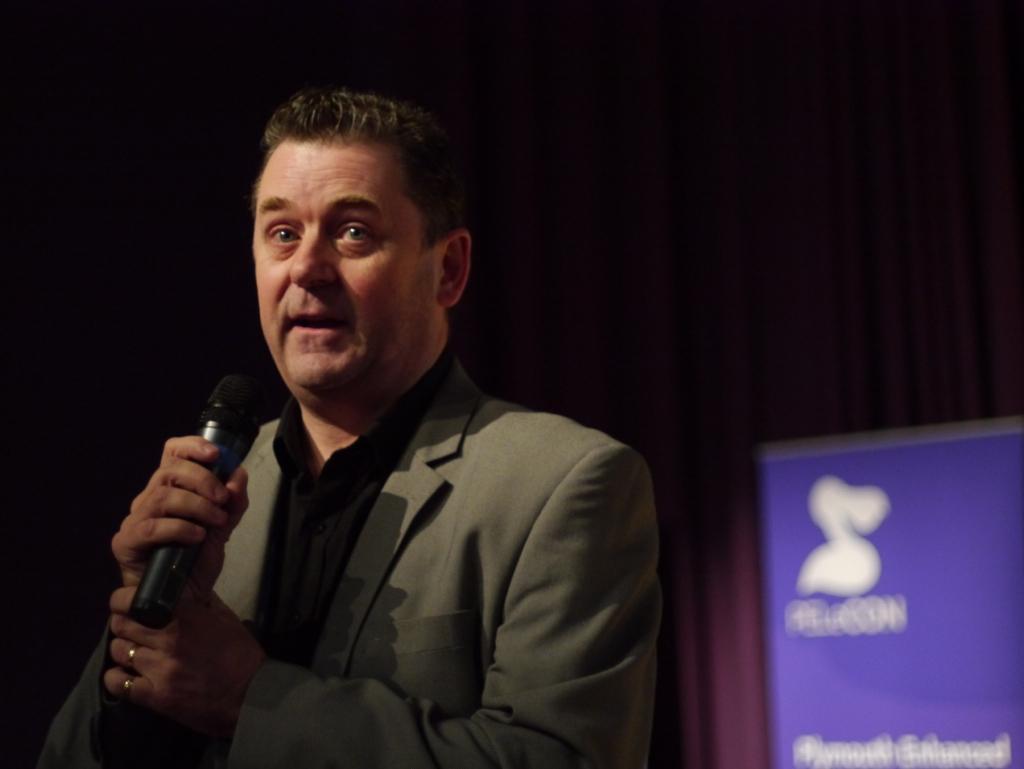Describe this image in one or two sentences. In this picture a man is standing and he is talking with the help of microphone, in the background we can see a hoarding. 